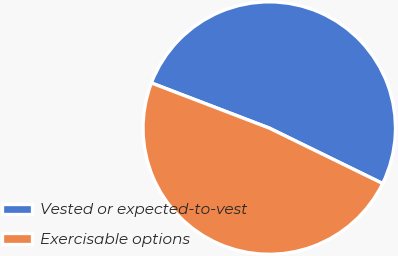Convert chart to OTSL. <chart><loc_0><loc_0><loc_500><loc_500><pie_chart><fcel>Vested or expected-to-vest<fcel>Exercisable options<nl><fcel>51.42%<fcel>48.58%<nl></chart> 